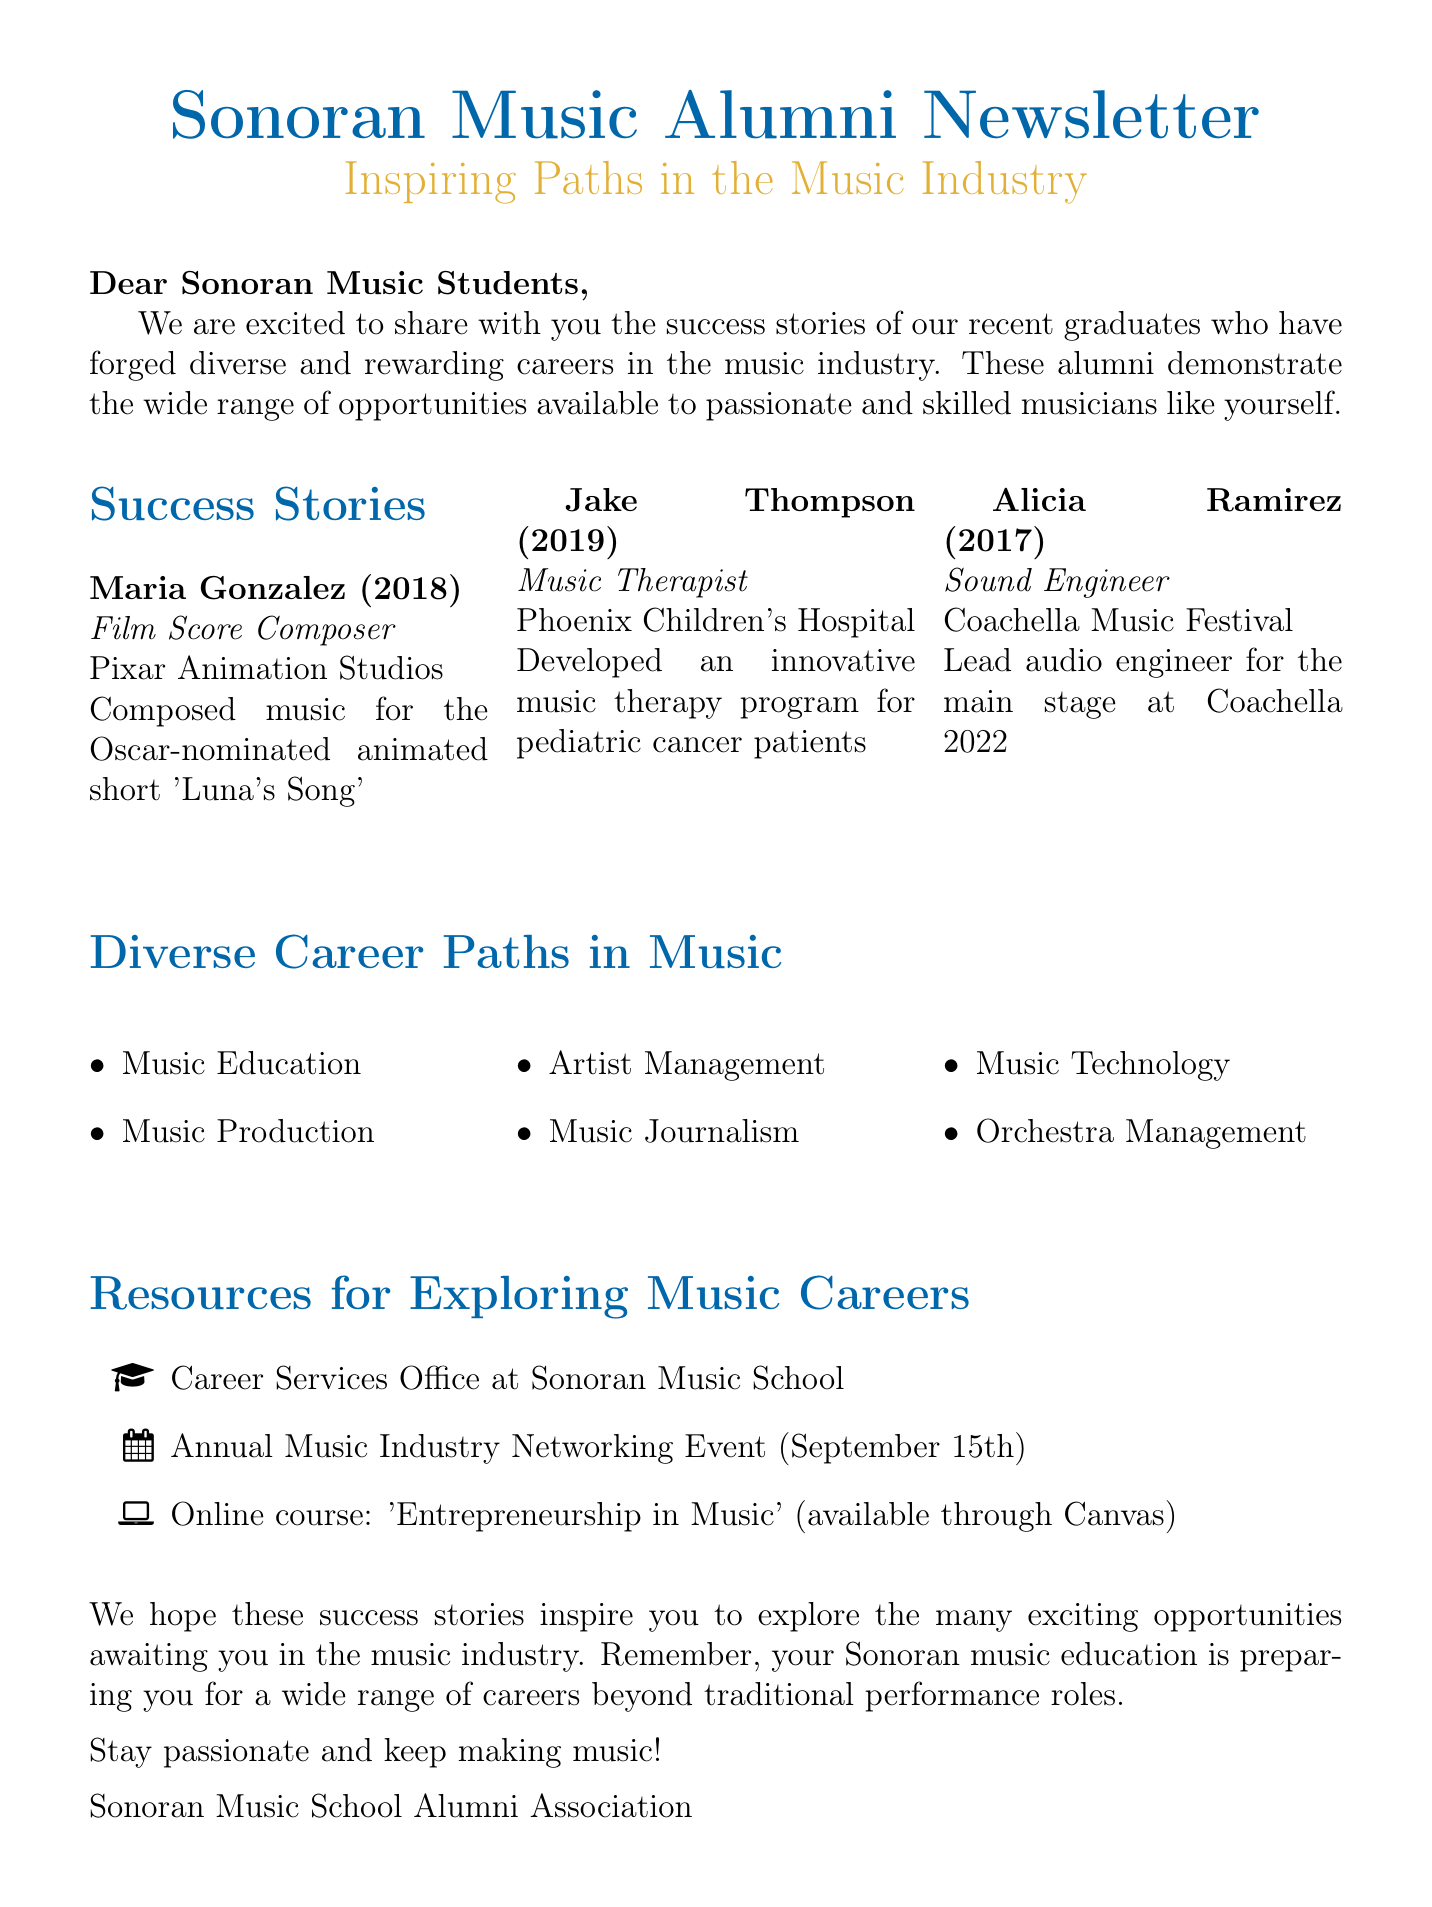what is the title of the newsletter? The title of the newsletter is presented at the top of the document, emphasizing its focus on alumni success.
Answer: Sonoran Music Alumni Newsletter: Inspiring Paths in the Music Industry who is a film score composer mentioned in the success stories? One of the alumni featured in the success stories is a film score composer recognized for their achievements.
Answer: Maria Gonzalez what year did Alicia Ramirez graduate? The graduation year for Alicia Ramirez is specified in the document under her success story.
Answer: 2017 how many career paths in music are listed? The document provides a list of career paths related to music education, which can be quantified.
Answer: 6 what is the focus of Jake Thompson's career? The document describes Jake Thompson’s career path and his specific role in the music industry.
Answer: Music Therapist what major achievement is highlighted for Maria Gonzalez? The document mentions a significant achievement associated with Maria Gonzalez, showcasing her talent and recognition.
Answer: Composed music for the Oscar-nominated animated short 'Luna's Song' when is the annual music industry networking event? The document states the specific date for an important networking event for music professionals.
Answer: September 15th which company did Alicia Ramirez work for? Information about the company where Alicia Ramirez is employed is provided in her success story.
Answer: Coachella Music Festival what type of course is offered online according to the resources section? The resources for music careers include an online course that focuses on a specific aspect of the music industry.
Answer: Entrepreneurship in Music 